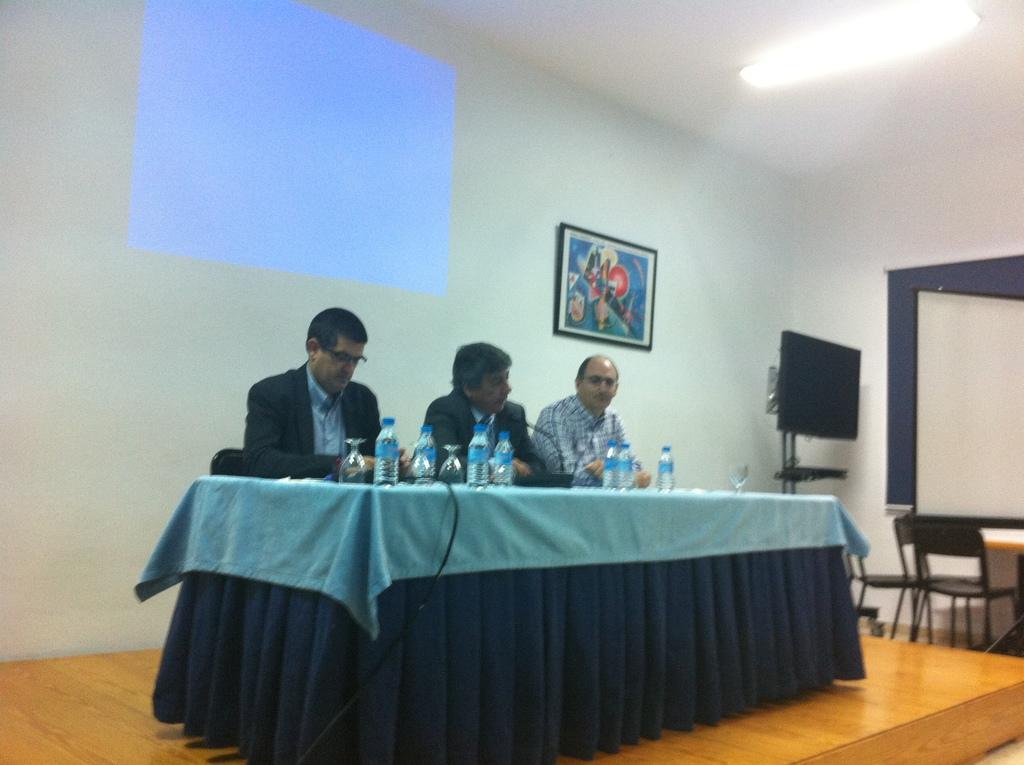Can you describe this image briefly? In the image we can see there are people who are sitting on chair. 